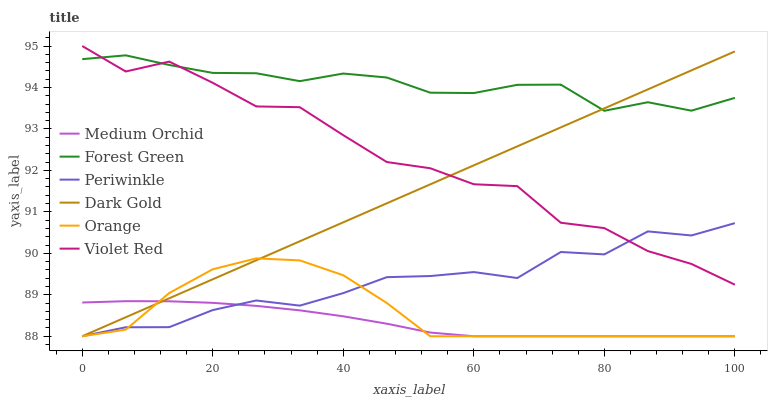Does Medium Orchid have the minimum area under the curve?
Answer yes or no. Yes. Does Forest Green have the maximum area under the curve?
Answer yes or no. Yes. Does Dark Gold have the minimum area under the curve?
Answer yes or no. No. Does Dark Gold have the maximum area under the curve?
Answer yes or no. No. Is Dark Gold the smoothest?
Answer yes or no. Yes. Is Violet Red the roughest?
Answer yes or no. Yes. Is Medium Orchid the smoothest?
Answer yes or no. No. Is Medium Orchid the roughest?
Answer yes or no. No. Does Dark Gold have the lowest value?
Answer yes or no. Yes. Does Forest Green have the lowest value?
Answer yes or no. No. Does Violet Red have the highest value?
Answer yes or no. Yes. Does Dark Gold have the highest value?
Answer yes or no. No. Is Orange less than Forest Green?
Answer yes or no. Yes. Is Violet Red greater than Medium Orchid?
Answer yes or no. Yes. Does Forest Green intersect Dark Gold?
Answer yes or no. Yes. Is Forest Green less than Dark Gold?
Answer yes or no. No. Is Forest Green greater than Dark Gold?
Answer yes or no. No. Does Orange intersect Forest Green?
Answer yes or no. No. 